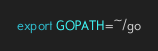Convert code to text. <code><loc_0><loc_0><loc_500><loc_500><_Bash_>export GOPATH=~/go
</code> 